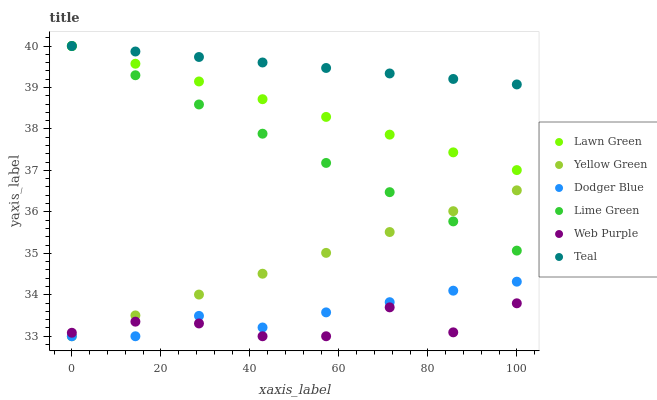Does Web Purple have the minimum area under the curve?
Answer yes or no. Yes. Does Teal have the maximum area under the curve?
Answer yes or no. Yes. Does Yellow Green have the minimum area under the curve?
Answer yes or no. No. Does Yellow Green have the maximum area under the curve?
Answer yes or no. No. Is Yellow Green the smoothest?
Answer yes or no. Yes. Is Web Purple the roughest?
Answer yes or no. Yes. Is Web Purple the smoothest?
Answer yes or no. No. Is Yellow Green the roughest?
Answer yes or no. No. Does Yellow Green have the lowest value?
Answer yes or no. Yes. Does Teal have the lowest value?
Answer yes or no. No. Does Lime Green have the highest value?
Answer yes or no. Yes. Does Yellow Green have the highest value?
Answer yes or no. No. Is Dodger Blue less than Lime Green?
Answer yes or no. Yes. Is Lawn Green greater than Yellow Green?
Answer yes or no. Yes. Does Lime Green intersect Teal?
Answer yes or no. Yes. Is Lime Green less than Teal?
Answer yes or no. No. Is Lime Green greater than Teal?
Answer yes or no. No. Does Dodger Blue intersect Lime Green?
Answer yes or no. No. 